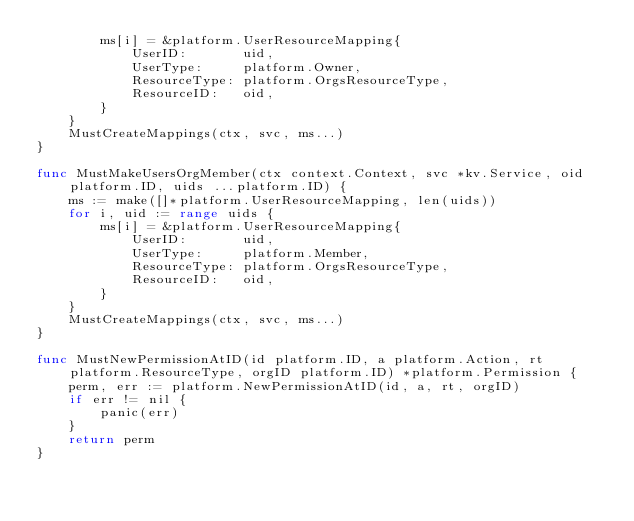<code> <loc_0><loc_0><loc_500><loc_500><_Go_>		ms[i] = &platform.UserResourceMapping{
			UserID:       uid,
			UserType:     platform.Owner,
			ResourceType: platform.OrgsResourceType,
			ResourceID:   oid,
		}
	}
	MustCreateMappings(ctx, svc, ms...)
}

func MustMakeUsersOrgMember(ctx context.Context, svc *kv.Service, oid platform.ID, uids ...platform.ID) {
	ms := make([]*platform.UserResourceMapping, len(uids))
	for i, uid := range uids {
		ms[i] = &platform.UserResourceMapping{
			UserID:       uid,
			UserType:     platform.Member,
			ResourceType: platform.OrgsResourceType,
			ResourceID:   oid,
		}
	}
	MustCreateMappings(ctx, svc, ms...)
}

func MustNewPermissionAtID(id platform.ID, a platform.Action, rt platform.ResourceType, orgID platform.ID) *platform.Permission {
	perm, err := platform.NewPermissionAtID(id, a, rt, orgID)
	if err != nil {
		panic(err)
	}
	return perm
}
</code> 